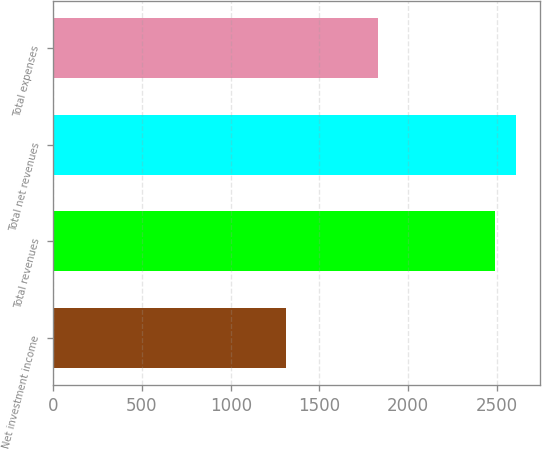Convert chart. <chart><loc_0><loc_0><loc_500><loc_500><bar_chart><fcel>Net investment income<fcel>Total revenues<fcel>Total net revenues<fcel>Total expenses<nl><fcel>1309<fcel>2491<fcel>2609.2<fcel>1827<nl></chart> 